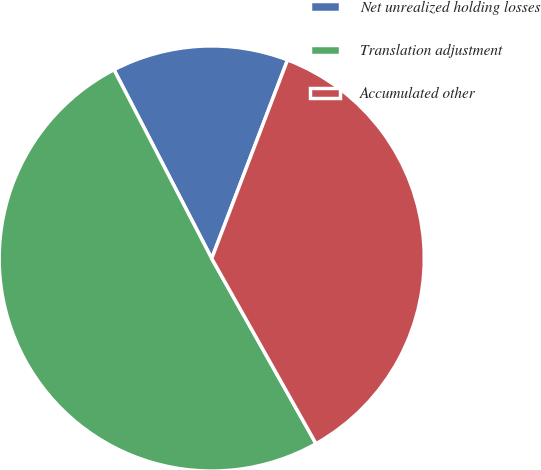<chart> <loc_0><loc_0><loc_500><loc_500><pie_chart><fcel>Net unrealized holding losses<fcel>Translation adjustment<fcel>Accumulated other<nl><fcel>13.41%<fcel>50.56%<fcel>36.03%<nl></chart> 